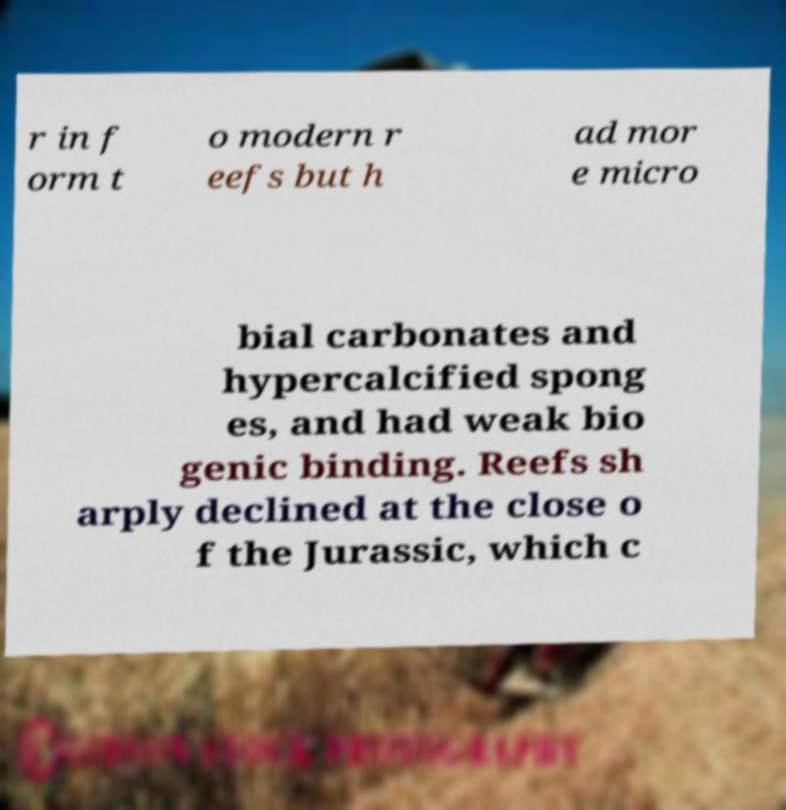For documentation purposes, I need the text within this image transcribed. Could you provide that? r in f orm t o modern r eefs but h ad mor e micro bial carbonates and hypercalcified spong es, and had weak bio genic binding. Reefs sh arply declined at the close o f the Jurassic, which c 